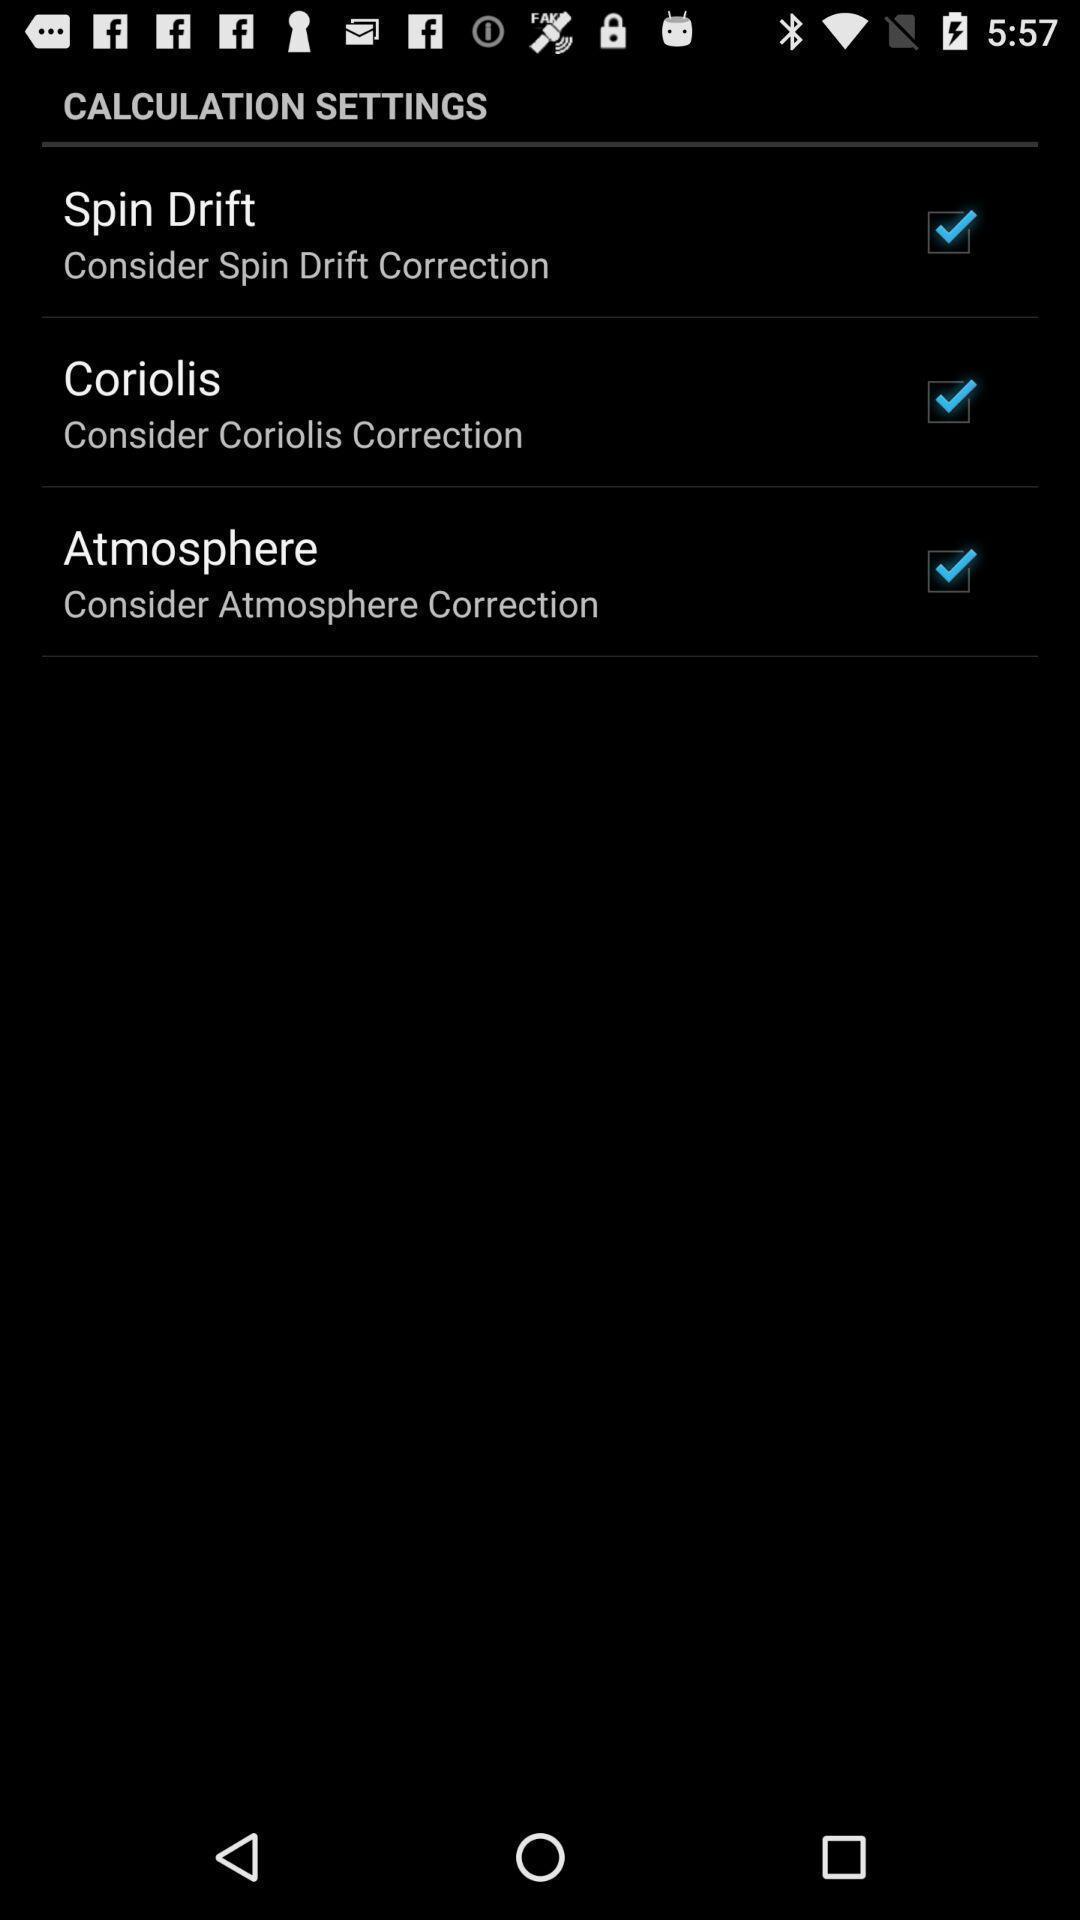Describe the content in this image. Screen shows about calculation settings. 